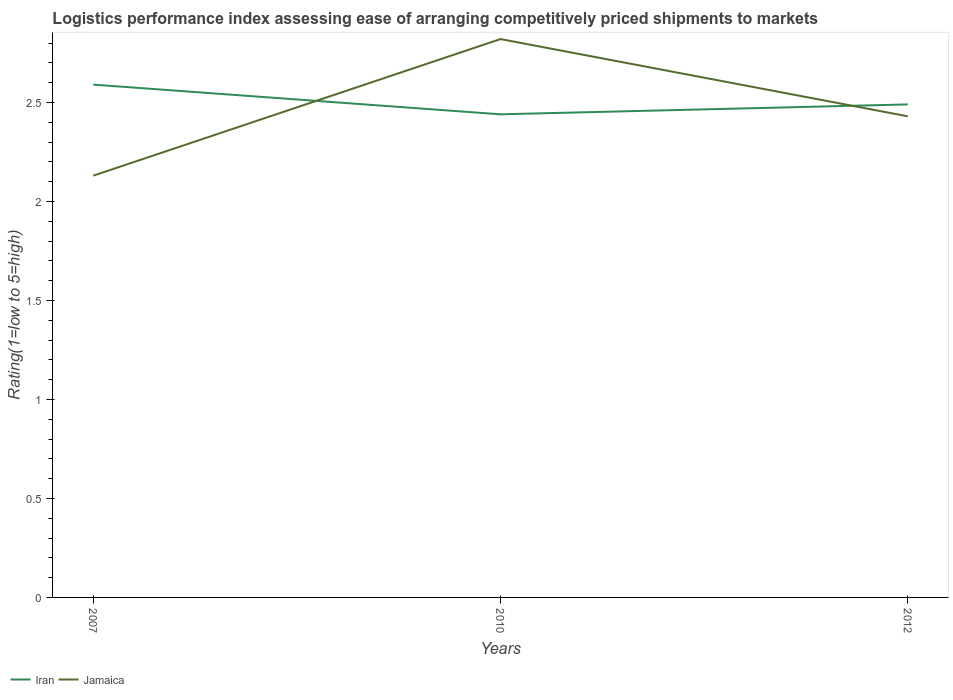Does the line corresponding to Iran intersect with the line corresponding to Jamaica?
Provide a succinct answer. Yes. Is the number of lines equal to the number of legend labels?
Offer a terse response. Yes. Across all years, what is the maximum Logistic performance index in Jamaica?
Your answer should be compact. 2.13. In which year was the Logistic performance index in Iran maximum?
Offer a terse response. 2010. What is the total Logistic performance index in Iran in the graph?
Provide a short and direct response. 0.1. What is the difference between the highest and the second highest Logistic performance index in Iran?
Your answer should be compact. 0.15. Is the Logistic performance index in Iran strictly greater than the Logistic performance index in Jamaica over the years?
Make the answer very short. No. How many lines are there?
Your answer should be very brief. 2. Are the values on the major ticks of Y-axis written in scientific E-notation?
Your answer should be very brief. No. Does the graph contain any zero values?
Make the answer very short. No. Does the graph contain grids?
Provide a short and direct response. No. Where does the legend appear in the graph?
Give a very brief answer. Bottom left. How many legend labels are there?
Provide a succinct answer. 2. What is the title of the graph?
Provide a short and direct response. Logistics performance index assessing ease of arranging competitively priced shipments to markets. Does "St. Kitts and Nevis" appear as one of the legend labels in the graph?
Keep it short and to the point. No. What is the label or title of the Y-axis?
Your response must be concise. Rating(1=low to 5=high). What is the Rating(1=low to 5=high) of Iran in 2007?
Your answer should be compact. 2.59. What is the Rating(1=low to 5=high) in Jamaica in 2007?
Ensure brevity in your answer.  2.13. What is the Rating(1=low to 5=high) in Iran in 2010?
Your answer should be very brief. 2.44. What is the Rating(1=low to 5=high) of Jamaica in 2010?
Give a very brief answer. 2.82. What is the Rating(1=low to 5=high) in Iran in 2012?
Make the answer very short. 2.49. What is the Rating(1=low to 5=high) in Jamaica in 2012?
Ensure brevity in your answer.  2.43. Across all years, what is the maximum Rating(1=low to 5=high) in Iran?
Make the answer very short. 2.59. Across all years, what is the maximum Rating(1=low to 5=high) in Jamaica?
Your answer should be very brief. 2.82. Across all years, what is the minimum Rating(1=low to 5=high) in Iran?
Your response must be concise. 2.44. Across all years, what is the minimum Rating(1=low to 5=high) in Jamaica?
Your answer should be very brief. 2.13. What is the total Rating(1=low to 5=high) of Iran in the graph?
Give a very brief answer. 7.52. What is the total Rating(1=low to 5=high) of Jamaica in the graph?
Provide a succinct answer. 7.38. What is the difference between the Rating(1=low to 5=high) of Iran in 2007 and that in 2010?
Ensure brevity in your answer.  0.15. What is the difference between the Rating(1=low to 5=high) in Jamaica in 2007 and that in 2010?
Give a very brief answer. -0.69. What is the difference between the Rating(1=low to 5=high) in Iran in 2010 and that in 2012?
Make the answer very short. -0.05. What is the difference between the Rating(1=low to 5=high) of Jamaica in 2010 and that in 2012?
Make the answer very short. 0.39. What is the difference between the Rating(1=low to 5=high) in Iran in 2007 and the Rating(1=low to 5=high) in Jamaica in 2010?
Make the answer very short. -0.23. What is the difference between the Rating(1=low to 5=high) of Iran in 2007 and the Rating(1=low to 5=high) of Jamaica in 2012?
Your answer should be very brief. 0.16. What is the average Rating(1=low to 5=high) in Iran per year?
Your answer should be compact. 2.51. What is the average Rating(1=low to 5=high) of Jamaica per year?
Ensure brevity in your answer.  2.46. In the year 2007, what is the difference between the Rating(1=low to 5=high) in Iran and Rating(1=low to 5=high) in Jamaica?
Your answer should be compact. 0.46. In the year 2010, what is the difference between the Rating(1=low to 5=high) of Iran and Rating(1=low to 5=high) of Jamaica?
Provide a succinct answer. -0.38. What is the ratio of the Rating(1=low to 5=high) in Iran in 2007 to that in 2010?
Your response must be concise. 1.06. What is the ratio of the Rating(1=low to 5=high) of Jamaica in 2007 to that in 2010?
Your answer should be very brief. 0.76. What is the ratio of the Rating(1=low to 5=high) in Iran in 2007 to that in 2012?
Your answer should be compact. 1.04. What is the ratio of the Rating(1=low to 5=high) of Jamaica in 2007 to that in 2012?
Your answer should be compact. 0.88. What is the ratio of the Rating(1=low to 5=high) in Iran in 2010 to that in 2012?
Your answer should be very brief. 0.98. What is the ratio of the Rating(1=low to 5=high) in Jamaica in 2010 to that in 2012?
Your response must be concise. 1.16. What is the difference between the highest and the second highest Rating(1=low to 5=high) in Iran?
Ensure brevity in your answer.  0.1. What is the difference between the highest and the second highest Rating(1=low to 5=high) of Jamaica?
Provide a short and direct response. 0.39. What is the difference between the highest and the lowest Rating(1=low to 5=high) of Iran?
Ensure brevity in your answer.  0.15. What is the difference between the highest and the lowest Rating(1=low to 5=high) in Jamaica?
Provide a short and direct response. 0.69. 